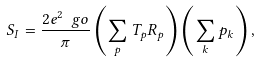Convert formula to latex. <formula><loc_0><loc_0><loc_500><loc_500>S _ { I } = \frac { 2 e ^ { 2 } \ g o } { \pi } \left ( \sum _ { p } T _ { p } R _ { p } \right ) \left ( \sum _ { k } p _ { k } \right ) ,</formula> 